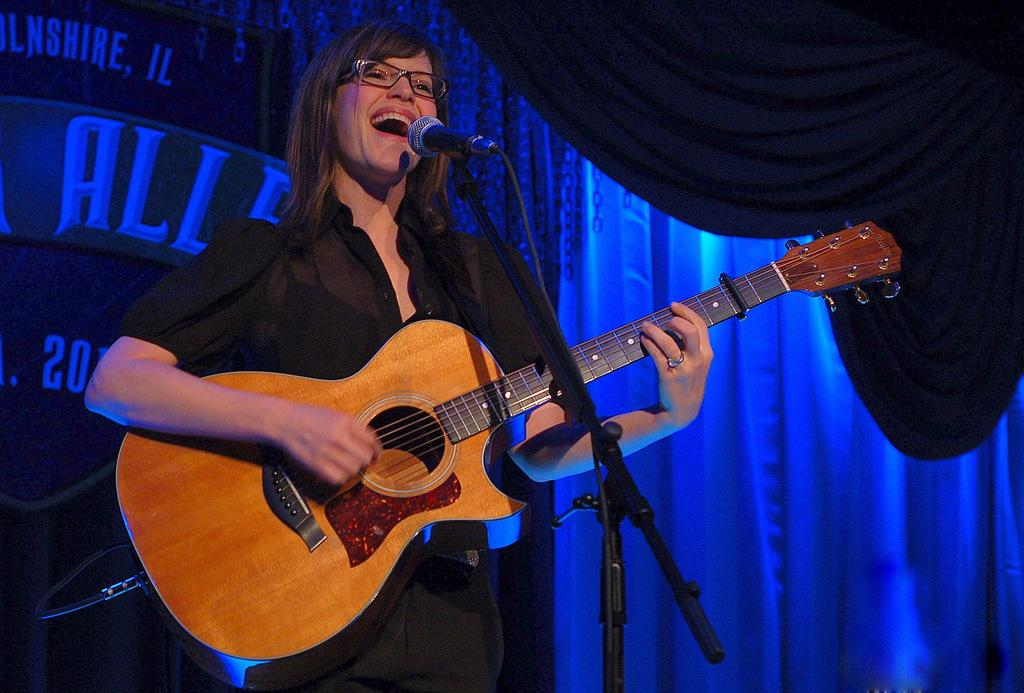Who is the main subject in the image? There is a woman in the image. What is the woman doing in the image? The woman is standing in front of a microphone, playing a guitar, and singing. What can be seen on the woman's face in the image? The woman is wearing spectacles. What is visible in the background of the image? There is a curtain and a board in the background of the image. How many parent snails can be seen carrying their fowl in the image? There are no snails, let alone parent snails carrying their fowl, present in the image. 